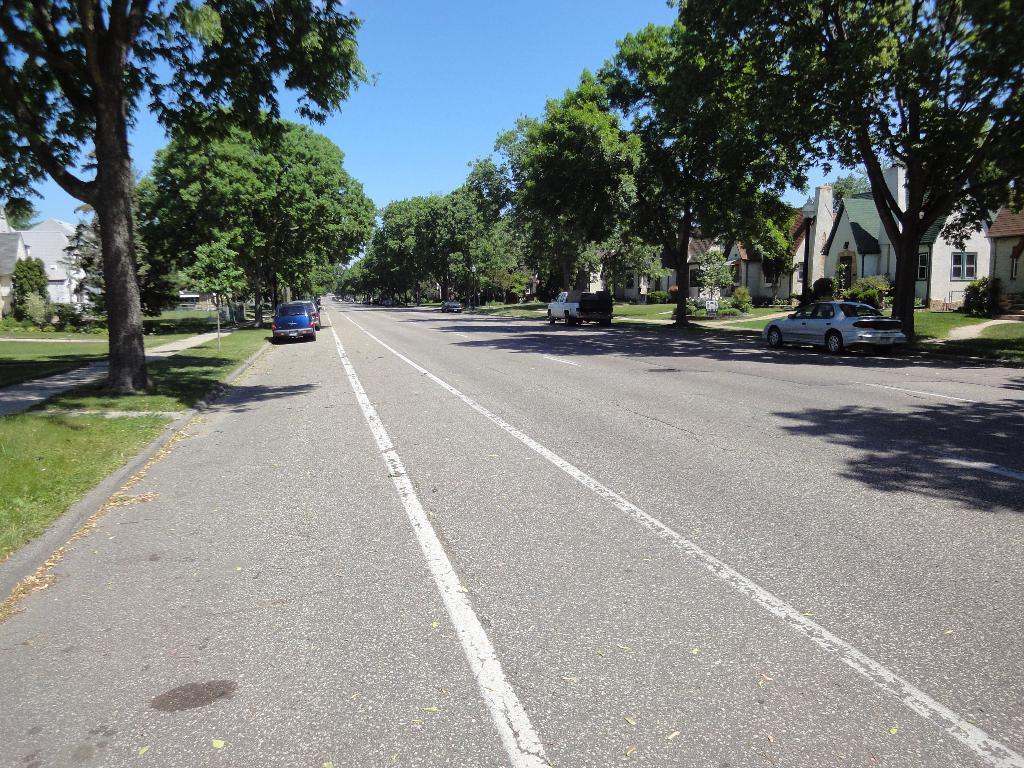Describe this image in one or two sentences. This picture is clicked outside. In the foreground we can see the concrete road. In the center we can see the vehicles seems to be parked on the ground and we can see the green grass, plants, trees and the houses and some other objects. In the background we can see the sky and the trees. 